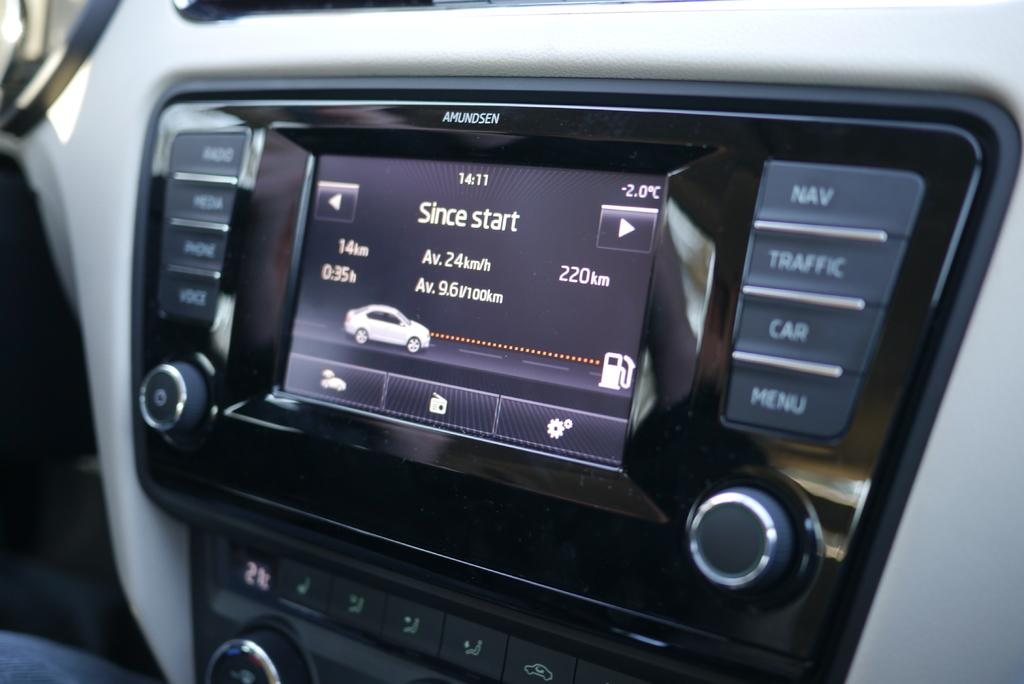What is the main subject of the image? The main subject of the image is a digital car cluster. What feature of the digital car cluster is mentioned in the facts? The digital car cluster has buttons. What type of wren can be seen perched on the digital car cluster in the image? There is no wren present in the image; the image only features a digital car cluster with buttons. What kind of marble is used to decorate the buttons on the digital car cluster? The buttons on the digital car cluster are not made of marble; they are mentioned as part of the digital car cluster itself. 